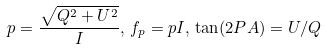Convert formula to latex. <formula><loc_0><loc_0><loc_500><loc_500>p = \frac { \sqrt { Q ^ { 2 } + U ^ { 2 } } } { I } , \, f _ { p } = p I , \, \tan ( 2 P A ) = U / Q</formula> 